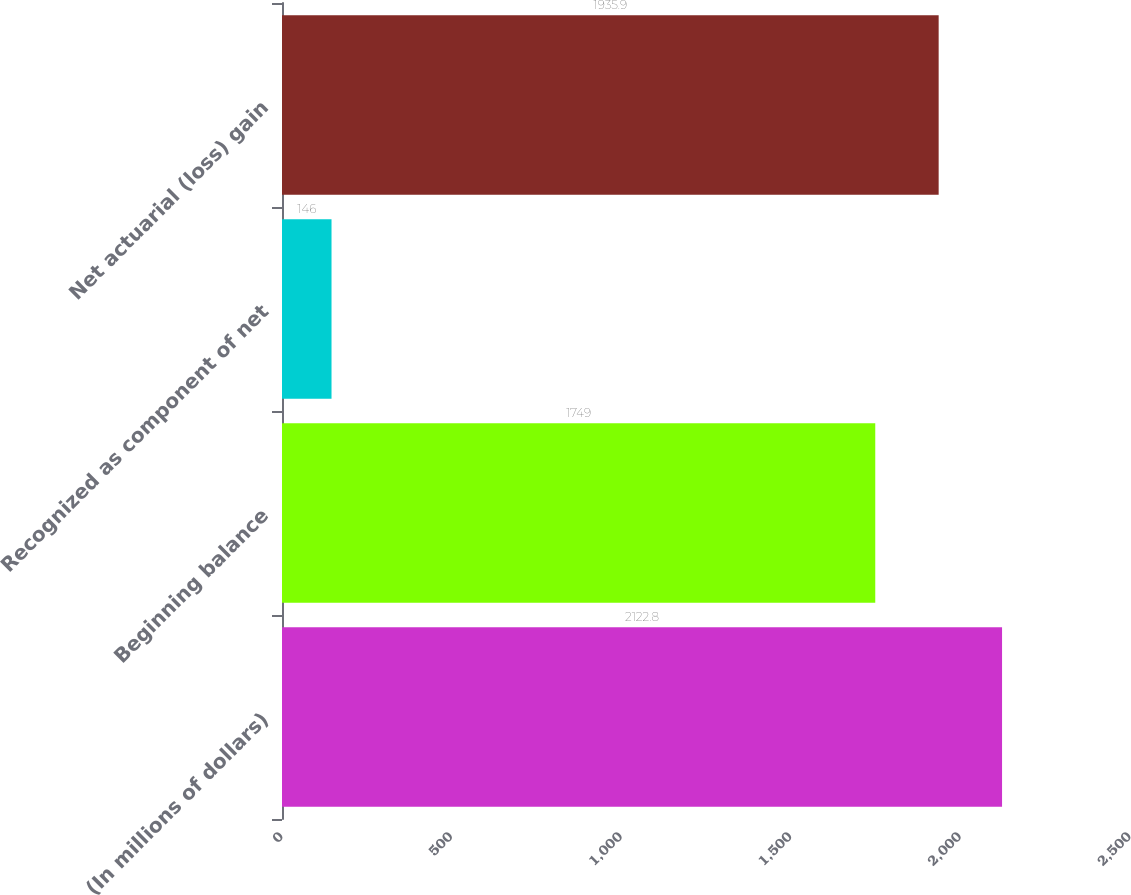<chart> <loc_0><loc_0><loc_500><loc_500><bar_chart><fcel>(In millions of dollars)<fcel>Beginning balance<fcel>Recognized as component of net<fcel>Net actuarial (loss) gain<nl><fcel>2122.8<fcel>1749<fcel>146<fcel>1935.9<nl></chart> 